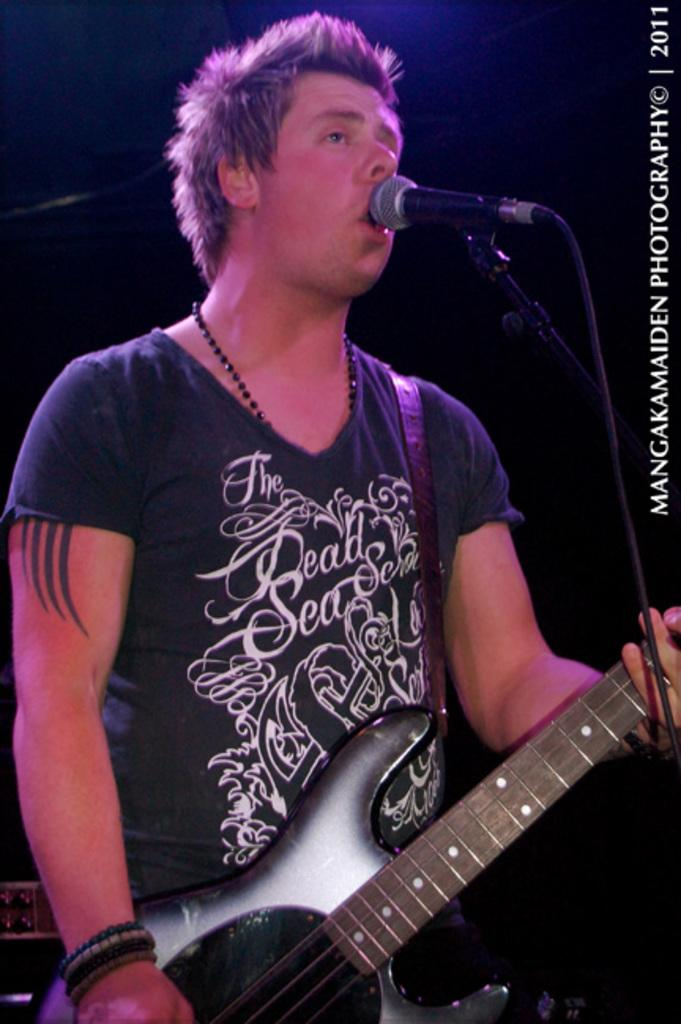What is the man in the image holding? The man is holding a guitar. What object is in front of the man? There is a microphone in front of the man. What type of crush is the man experiencing in the image? There is no indication in the image that the man is experiencing any type of crush. What rule is the man following in the image? There is no rule mentioned or implied in the image. 